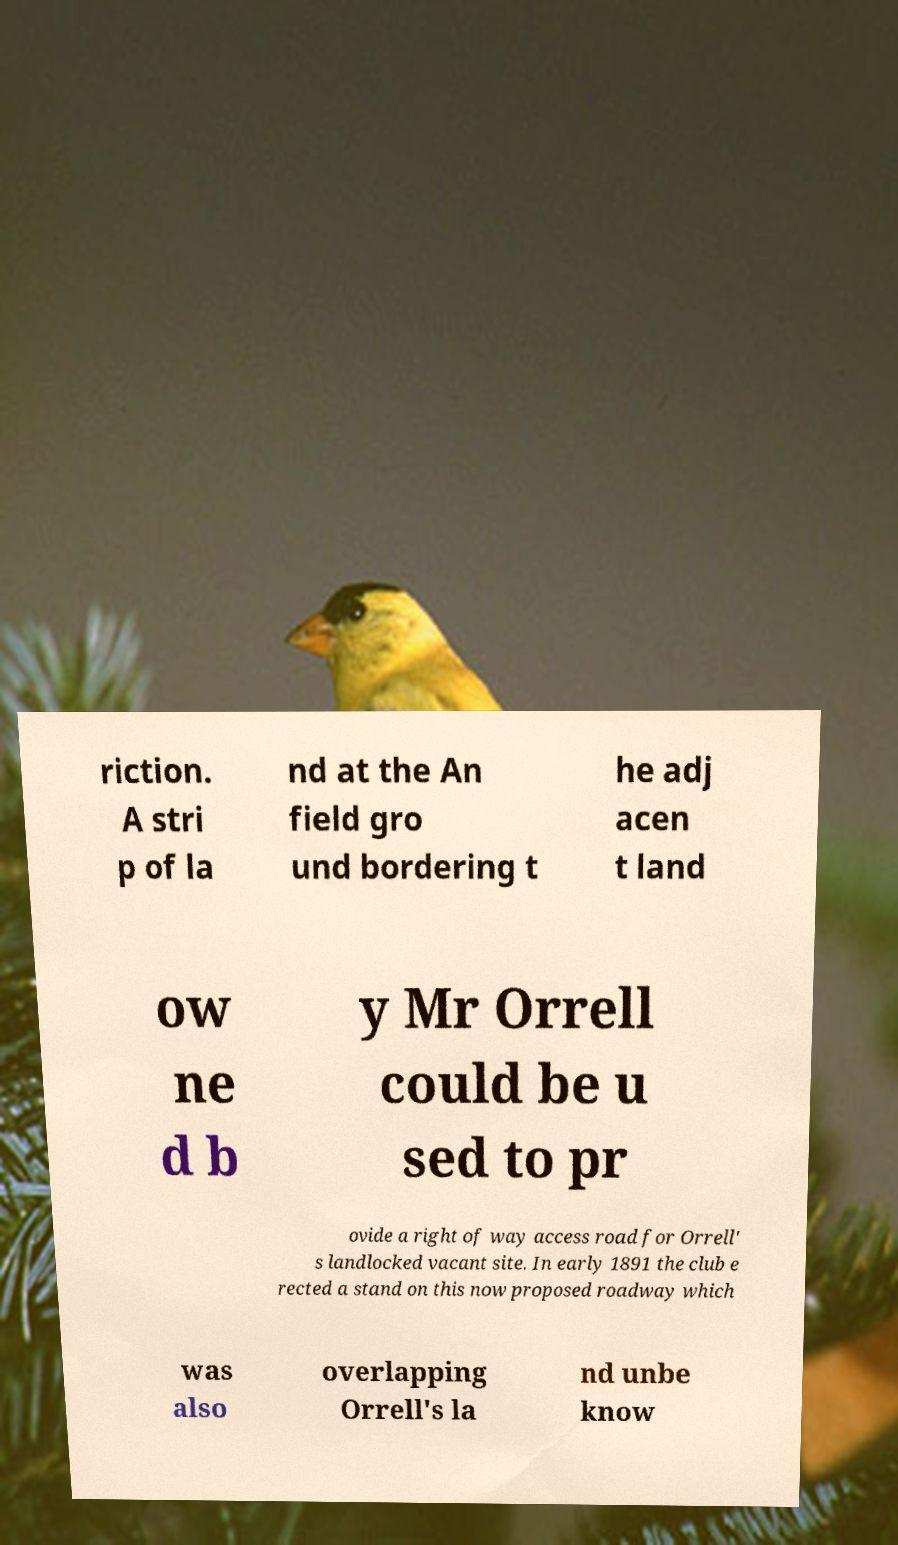There's text embedded in this image that I need extracted. Can you transcribe it verbatim? riction. A stri p of la nd at the An field gro und bordering t he adj acen t land ow ne d b y Mr Orrell could be u sed to pr ovide a right of way access road for Orrell' s landlocked vacant site. In early 1891 the club e rected a stand on this now proposed roadway which was also overlapping Orrell's la nd unbe know 